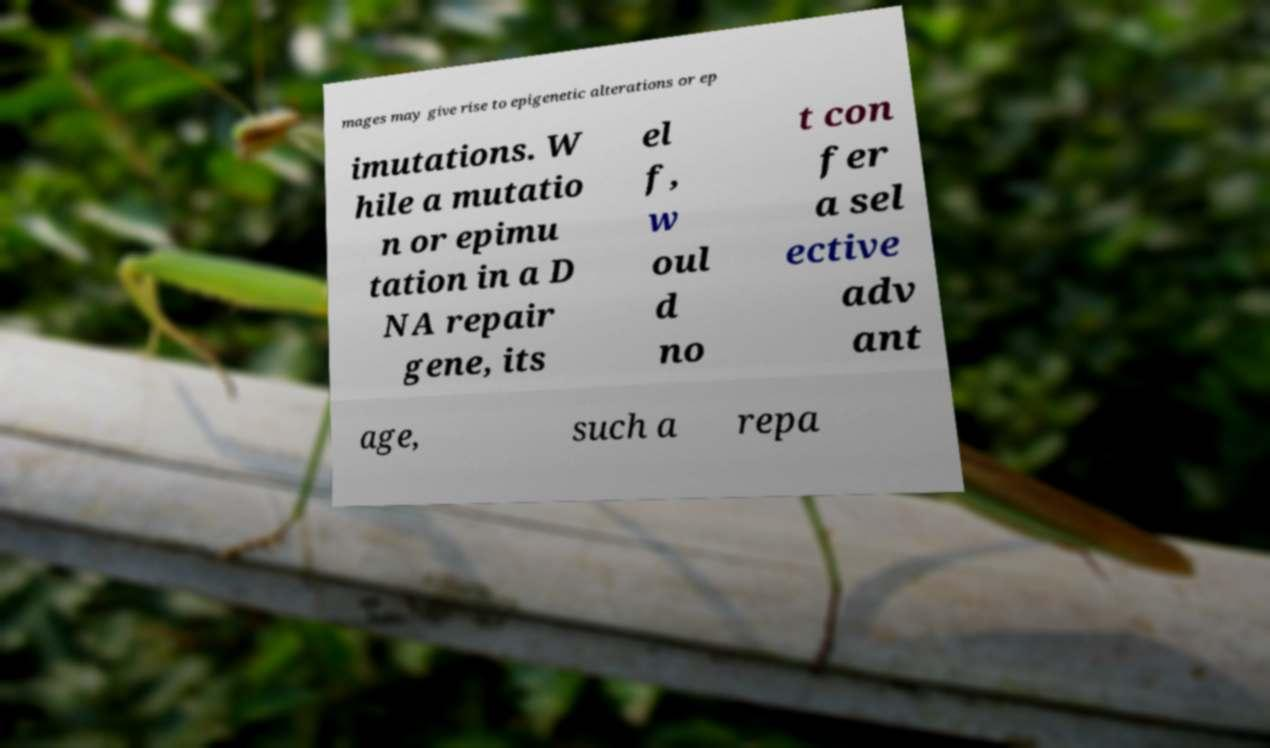Could you extract and type out the text from this image? mages may give rise to epigenetic alterations or ep imutations. W hile a mutatio n or epimu tation in a D NA repair gene, its el f, w oul d no t con fer a sel ective adv ant age, such a repa 